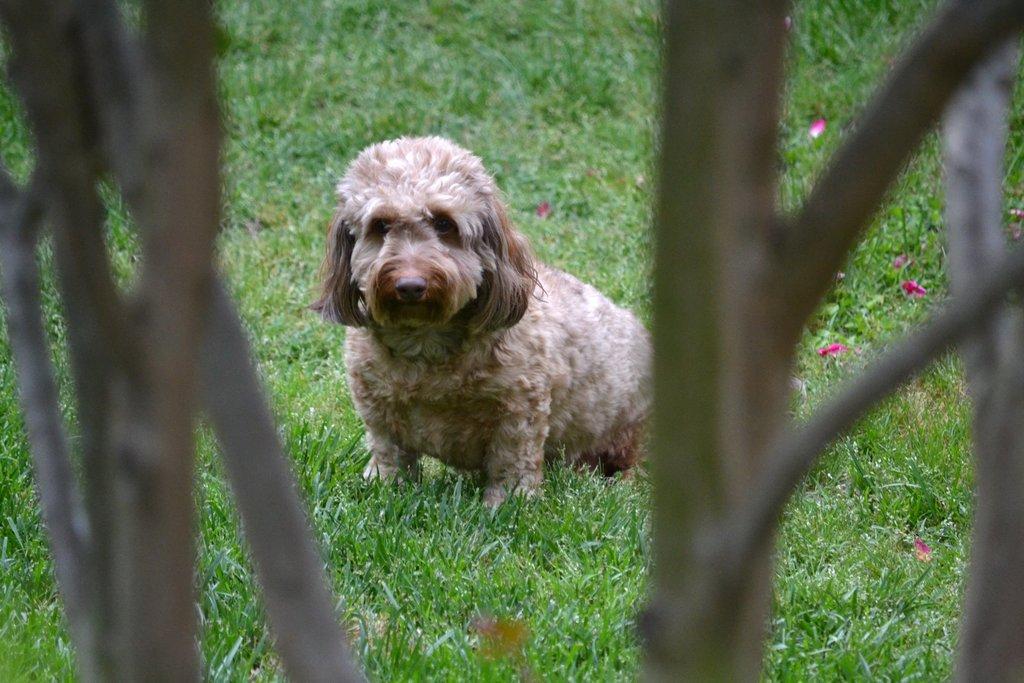Describe this image in one or two sentences. In this image, I can see a dog on the grass. On the left and right side of the image, these are looking like branches. 